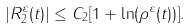Convert formula to latex. <formula><loc_0><loc_0><loc_500><loc_500>| R _ { 2 } ^ { \varepsilon } ( t ) | \leq C _ { 2 } [ 1 + \ln ( \rho ^ { \varepsilon } ( t ) ) ] .</formula> 